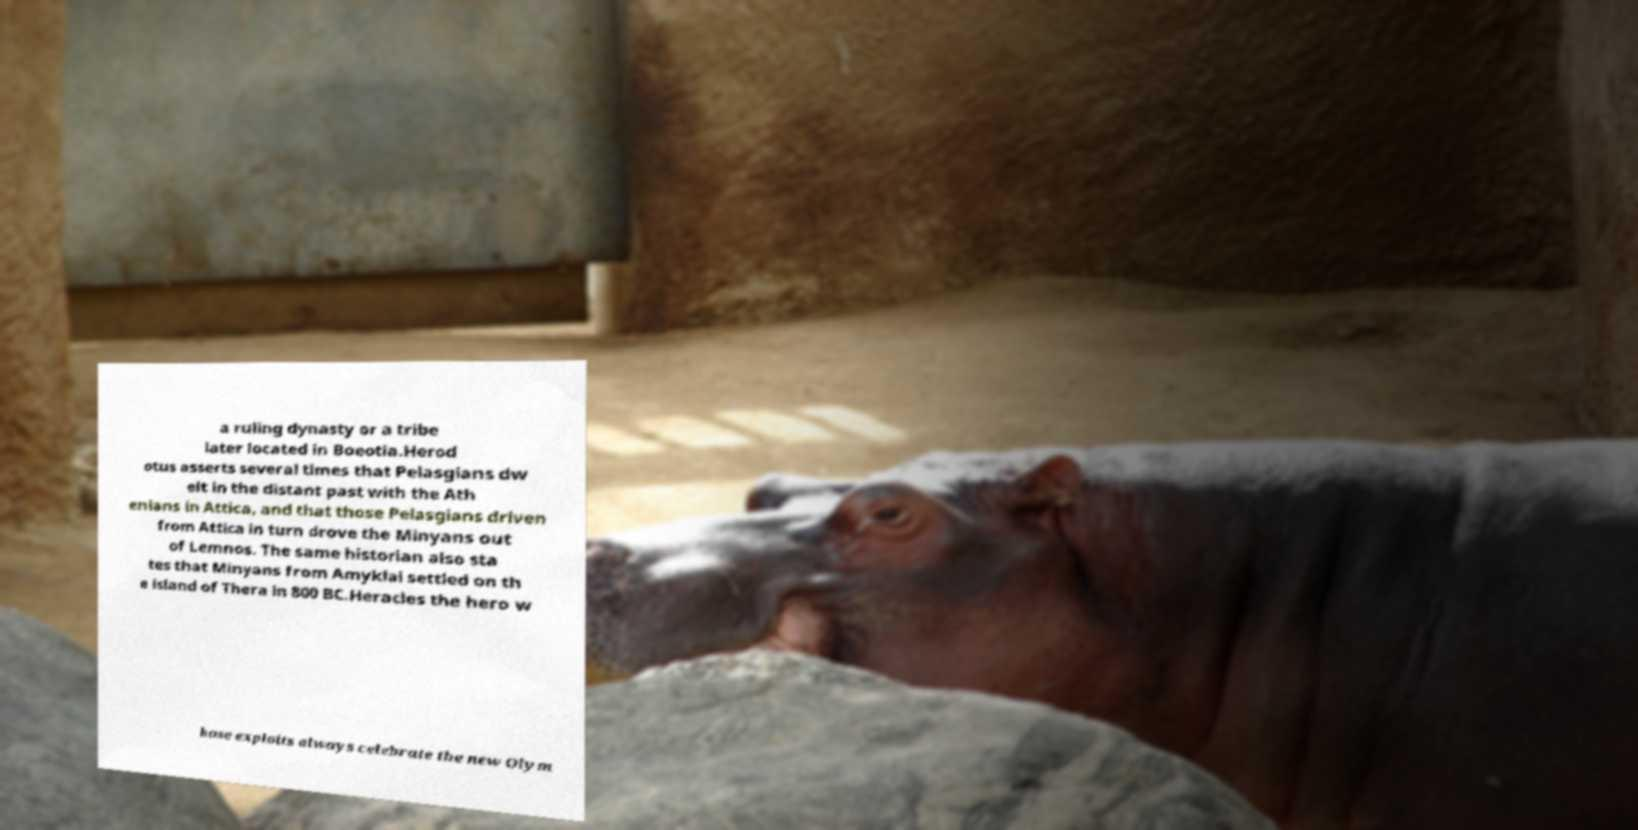Please identify and transcribe the text found in this image. a ruling dynasty or a tribe later located in Boeotia.Herod otus asserts several times that Pelasgians dw elt in the distant past with the Ath enians in Attica, and that those Pelasgians driven from Attica in turn drove the Minyans out of Lemnos. The same historian also sta tes that Minyans from Amyklai settled on th e island of Thera in 800 BC.Heracles the hero w hose exploits always celebrate the new Olym 